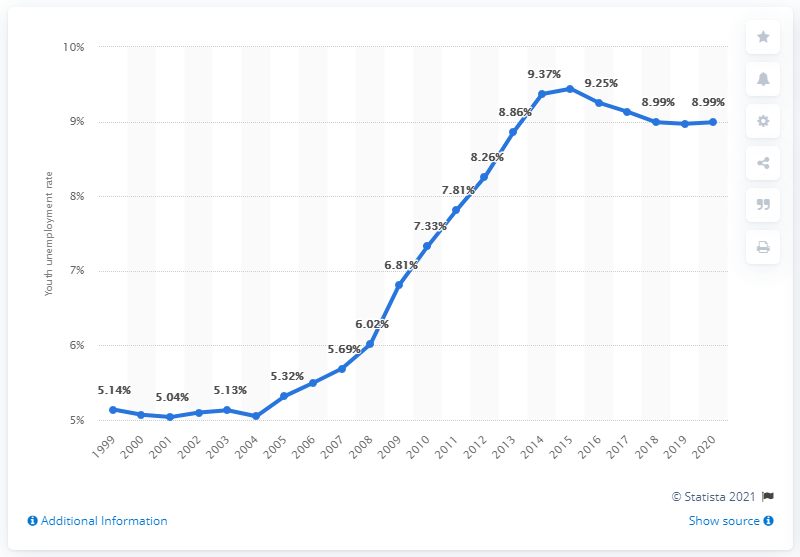List a handful of essential elements in this visual. In 2020, the youth unemployment rate in Sierra Leone was 8.99%. 